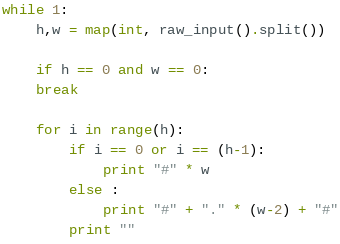Convert code to text. <code><loc_0><loc_0><loc_500><loc_500><_Python_>while 1:
    h,w = map(int, raw_input().split())

    if h == 0 and w == 0:
    break

    for i in range(h):
        if i == 0 or i == (h-1):
            print "#" * w
        else :
            print "#" + "." * (w-2) + "#"
        print ""</code> 